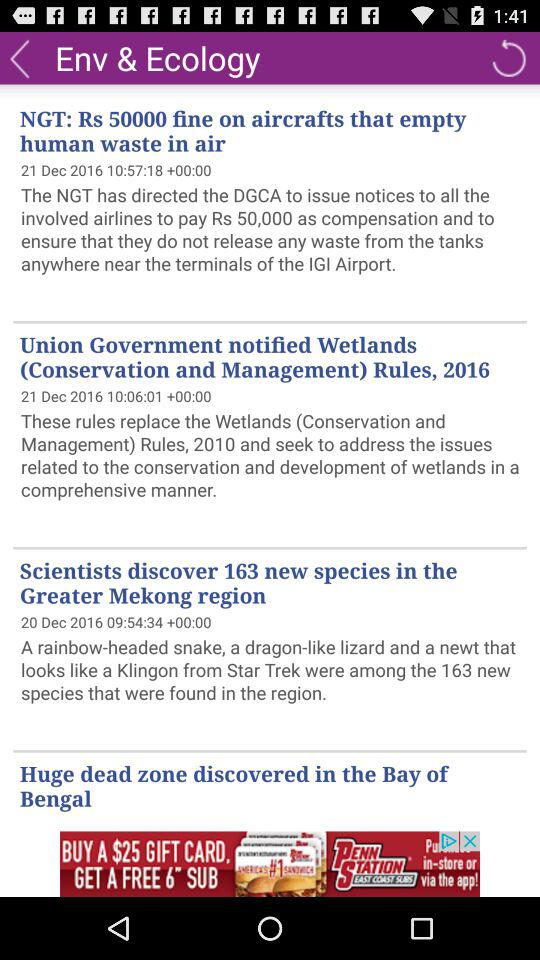How much of a fine was imposed on aircraft that emptied human waste into the air? On aircraft that emptied human waste into the air, a fine of 50000 rupees was imposed. 